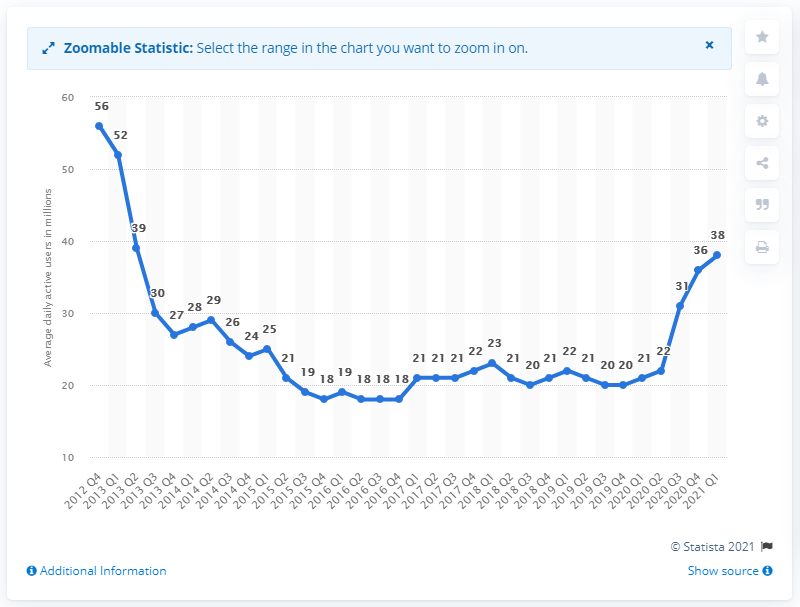Highlight a few significant elements in this photo. In the previous quarter, Zynga had approximately 36 million users. Zynga reported 38 daily active users in the first quarter of 2021. 